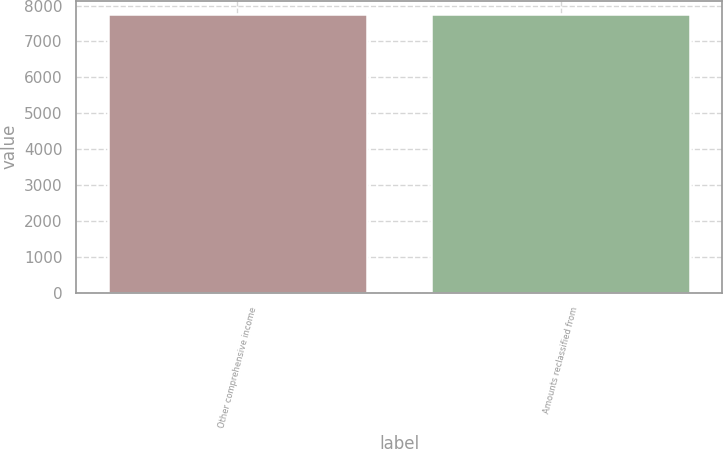Convert chart to OTSL. <chart><loc_0><loc_0><loc_500><loc_500><bar_chart><fcel>Other comprehensive income<fcel>Amounts reclassified from<nl><fcel>7752<fcel>7752.1<nl></chart> 